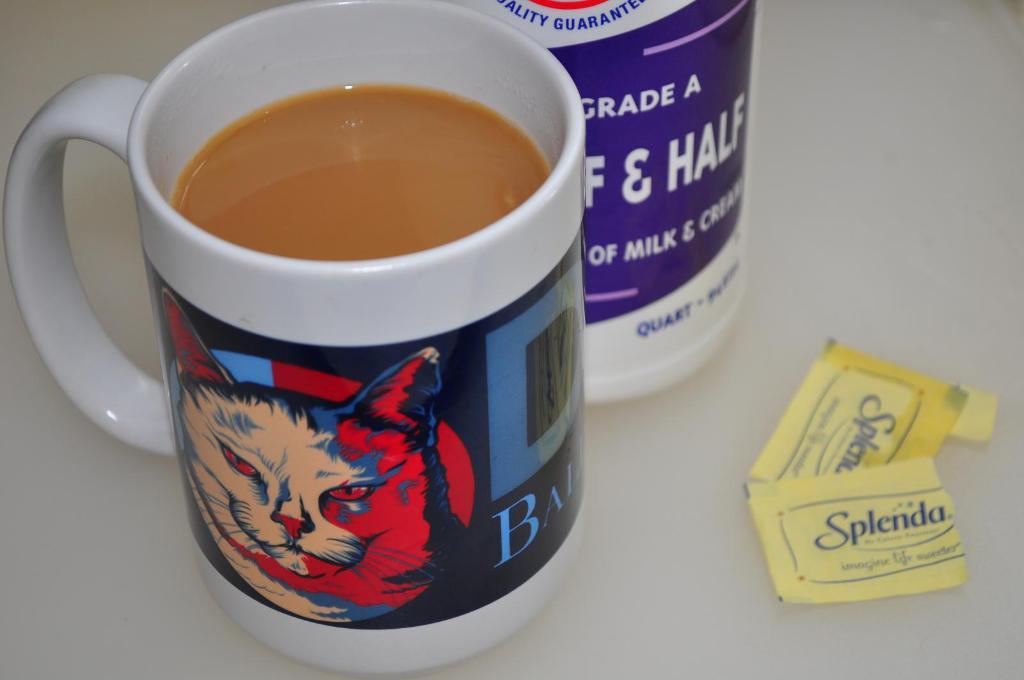What brand of sweetener did they use?
Offer a very short reply. Splenda. What grade was the half & half?
Ensure brevity in your answer.  A. 